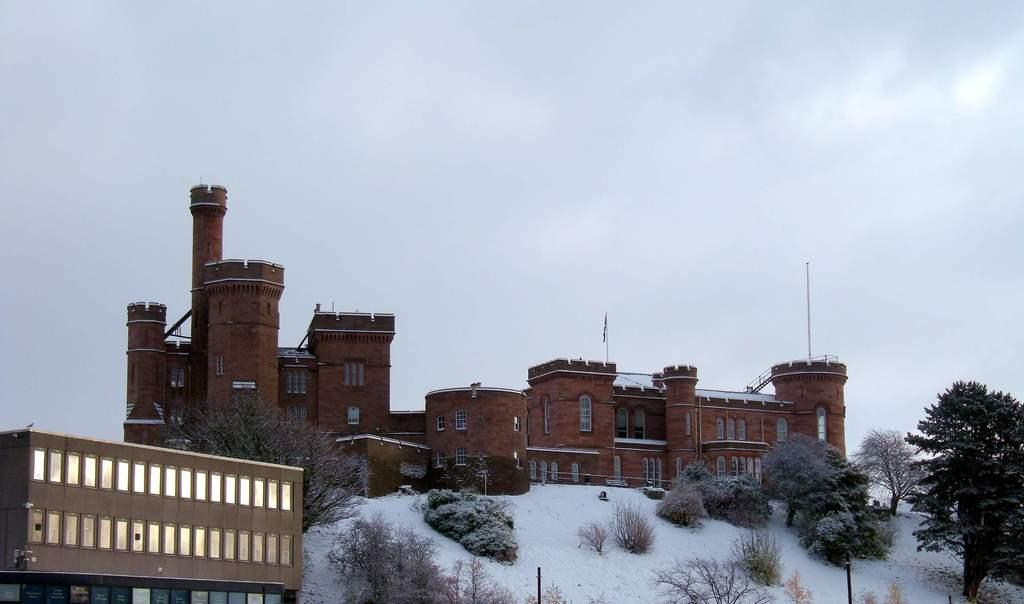What is the condition of the land in the image? The land is covered with snow. What type of vegetation can be seen on the land? There are trees on the land. What structures are present on the land? There are poles and buildings on the land. What is visible in the sky in the background of the image? The sky is covered with clouds in the background of the image. Can you see any marks left by ants on the snow in the image? There are no ants or marks left by ants visible in the image. Is there a battle taking place on the land in the image? There is no indication of a battle or any conflict in the image. 